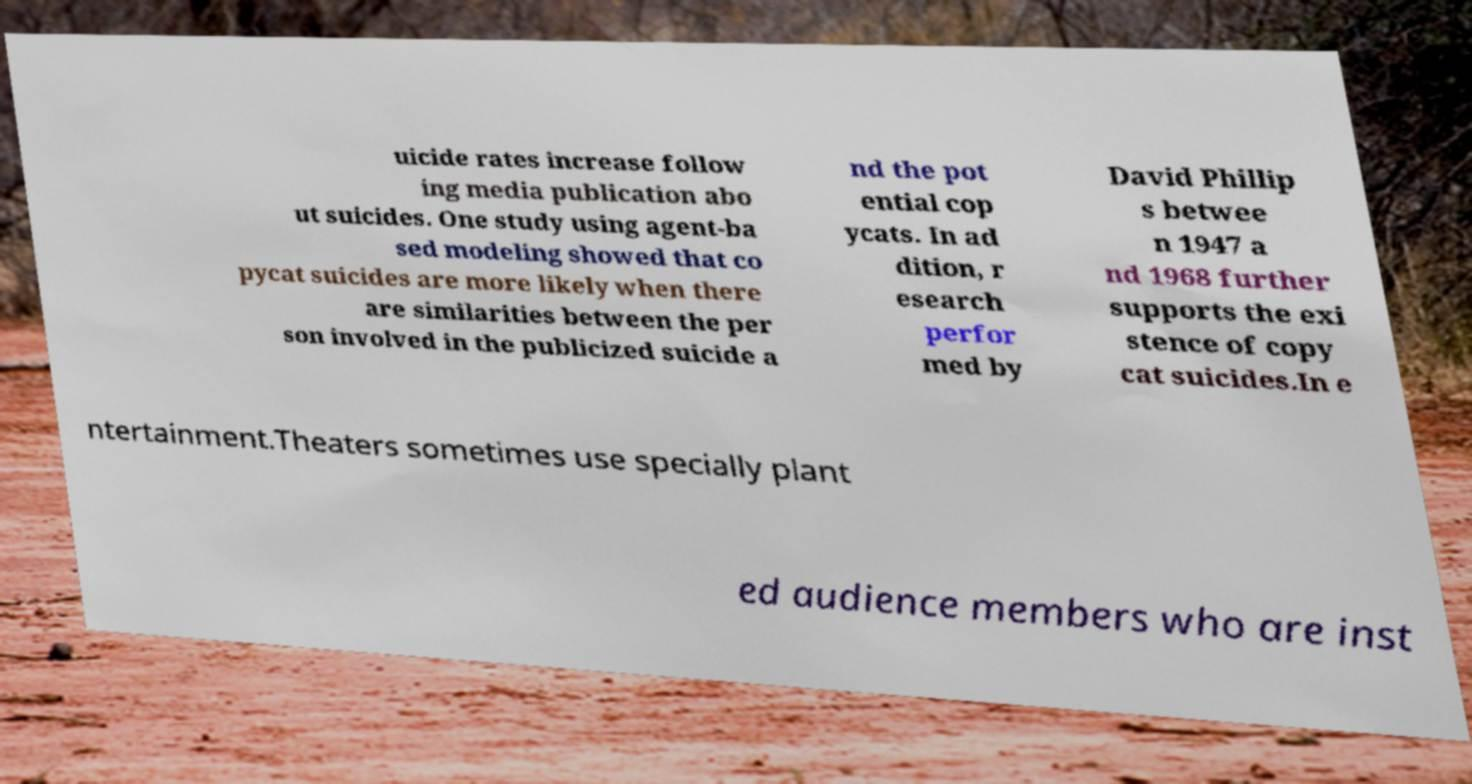Please identify and transcribe the text found in this image. uicide rates increase follow ing media publication abo ut suicides. One study using agent-ba sed modeling showed that co pycat suicides are more likely when there are similarities between the per son involved in the publicized suicide a nd the pot ential cop ycats. In ad dition, r esearch perfor med by David Phillip s betwee n 1947 a nd 1968 further supports the exi stence of copy cat suicides.In e ntertainment.Theaters sometimes use specially plant ed audience members who are inst 